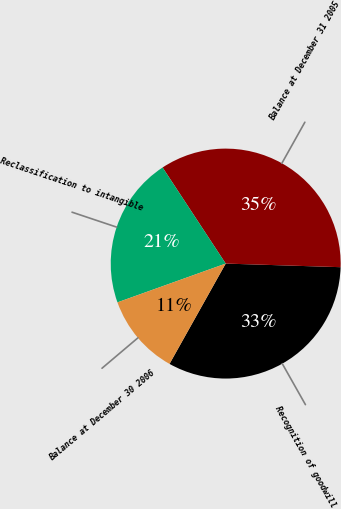Convert chart to OTSL. <chart><loc_0><loc_0><loc_500><loc_500><pie_chart><fcel>Recognition of goodwill<fcel>Balance at December 31 2005<fcel>Reclassification to intangible<fcel>Balance at December 30 2006<nl><fcel>32.63%<fcel>34.75%<fcel>21.23%<fcel>11.4%<nl></chart> 